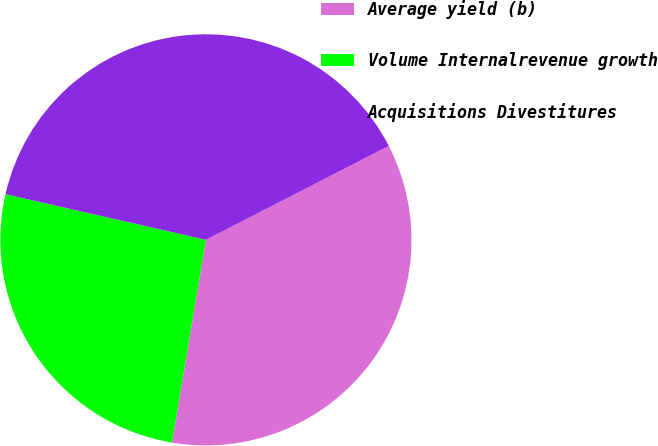<chart> <loc_0><loc_0><loc_500><loc_500><pie_chart><fcel>Average yield (b)<fcel>Volume Internalrevenue growth<fcel>Acquisitions Divestitures<nl><fcel>35.19%<fcel>25.93%<fcel>38.89%<nl></chart> 